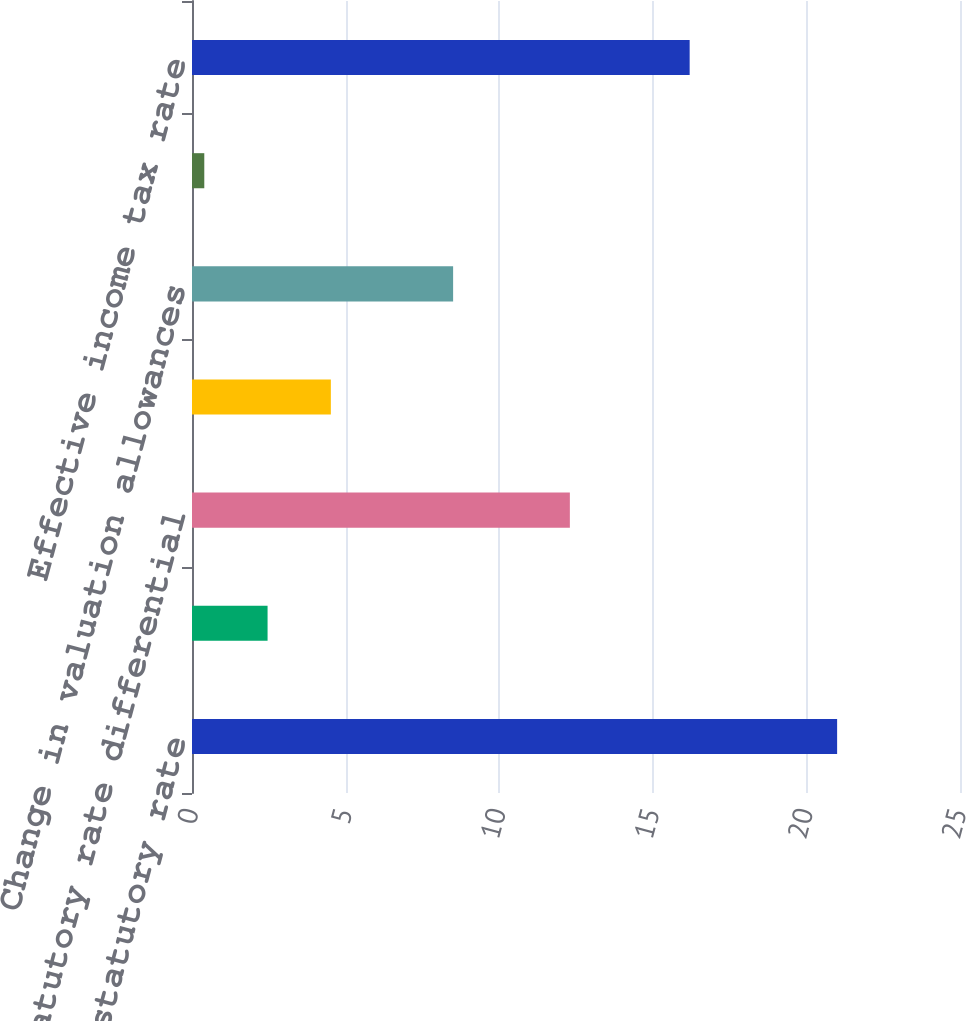Convert chart. <chart><loc_0><loc_0><loc_500><loc_500><bar_chart><fcel>US federal statutory rate<fcel>State income tax net of<fcel>Statutory rate differential<fcel>Adjustments to reserves and<fcel>Change in valuation allowances<fcel>Other net<fcel>Effective income tax rate<nl><fcel>21<fcel>2.46<fcel>12.3<fcel>4.52<fcel>8.5<fcel>0.4<fcel>16.2<nl></chart> 